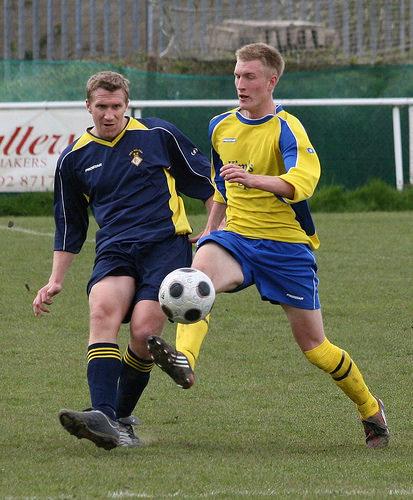<image>
Is there a net on the grass? Yes. Looking at the image, I can see the net is positioned on top of the grass, with the grass providing support. Is the ball on the player? No. The ball is not positioned on the player. They may be near each other, but the ball is not supported by or resting on top of the player. Where is the ball in relation to the man? Is it on the man? No. The ball is not positioned on the man. They may be near each other, but the ball is not supported by or resting on top of the man. Is there a ball to the right of the man? Yes. From this viewpoint, the ball is positioned to the right side relative to the man. 